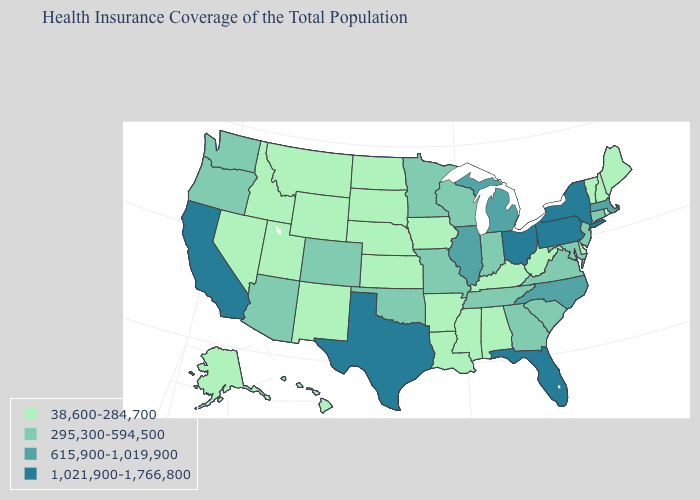Does the map have missing data?
Write a very short answer. No. Name the states that have a value in the range 38,600-284,700?
Write a very short answer. Alabama, Alaska, Arkansas, Delaware, Hawaii, Idaho, Iowa, Kansas, Kentucky, Louisiana, Maine, Mississippi, Montana, Nebraska, Nevada, New Hampshire, New Mexico, North Dakota, Rhode Island, South Dakota, Utah, Vermont, West Virginia, Wyoming. Among the states that border Kansas , which have the lowest value?
Be succinct. Nebraska. How many symbols are there in the legend?
Be succinct. 4. Does Kentucky have a higher value than Massachusetts?
Keep it brief. No. What is the highest value in the USA?
Quick response, please. 1,021,900-1,766,800. What is the value of New York?
Short answer required. 1,021,900-1,766,800. What is the lowest value in the West?
Answer briefly. 38,600-284,700. What is the value of Delaware?
Answer briefly. 38,600-284,700. Which states have the highest value in the USA?
Answer briefly. California, Florida, New York, Ohio, Pennsylvania, Texas. How many symbols are there in the legend?
Give a very brief answer. 4. How many symbols are there in the legend?
Give a very brief answer. 4. Among the states that border California , does Arizona have the lowest value?
Answer briefly. No. Which states hav the highest value in the West?
Concise answer only. California. 